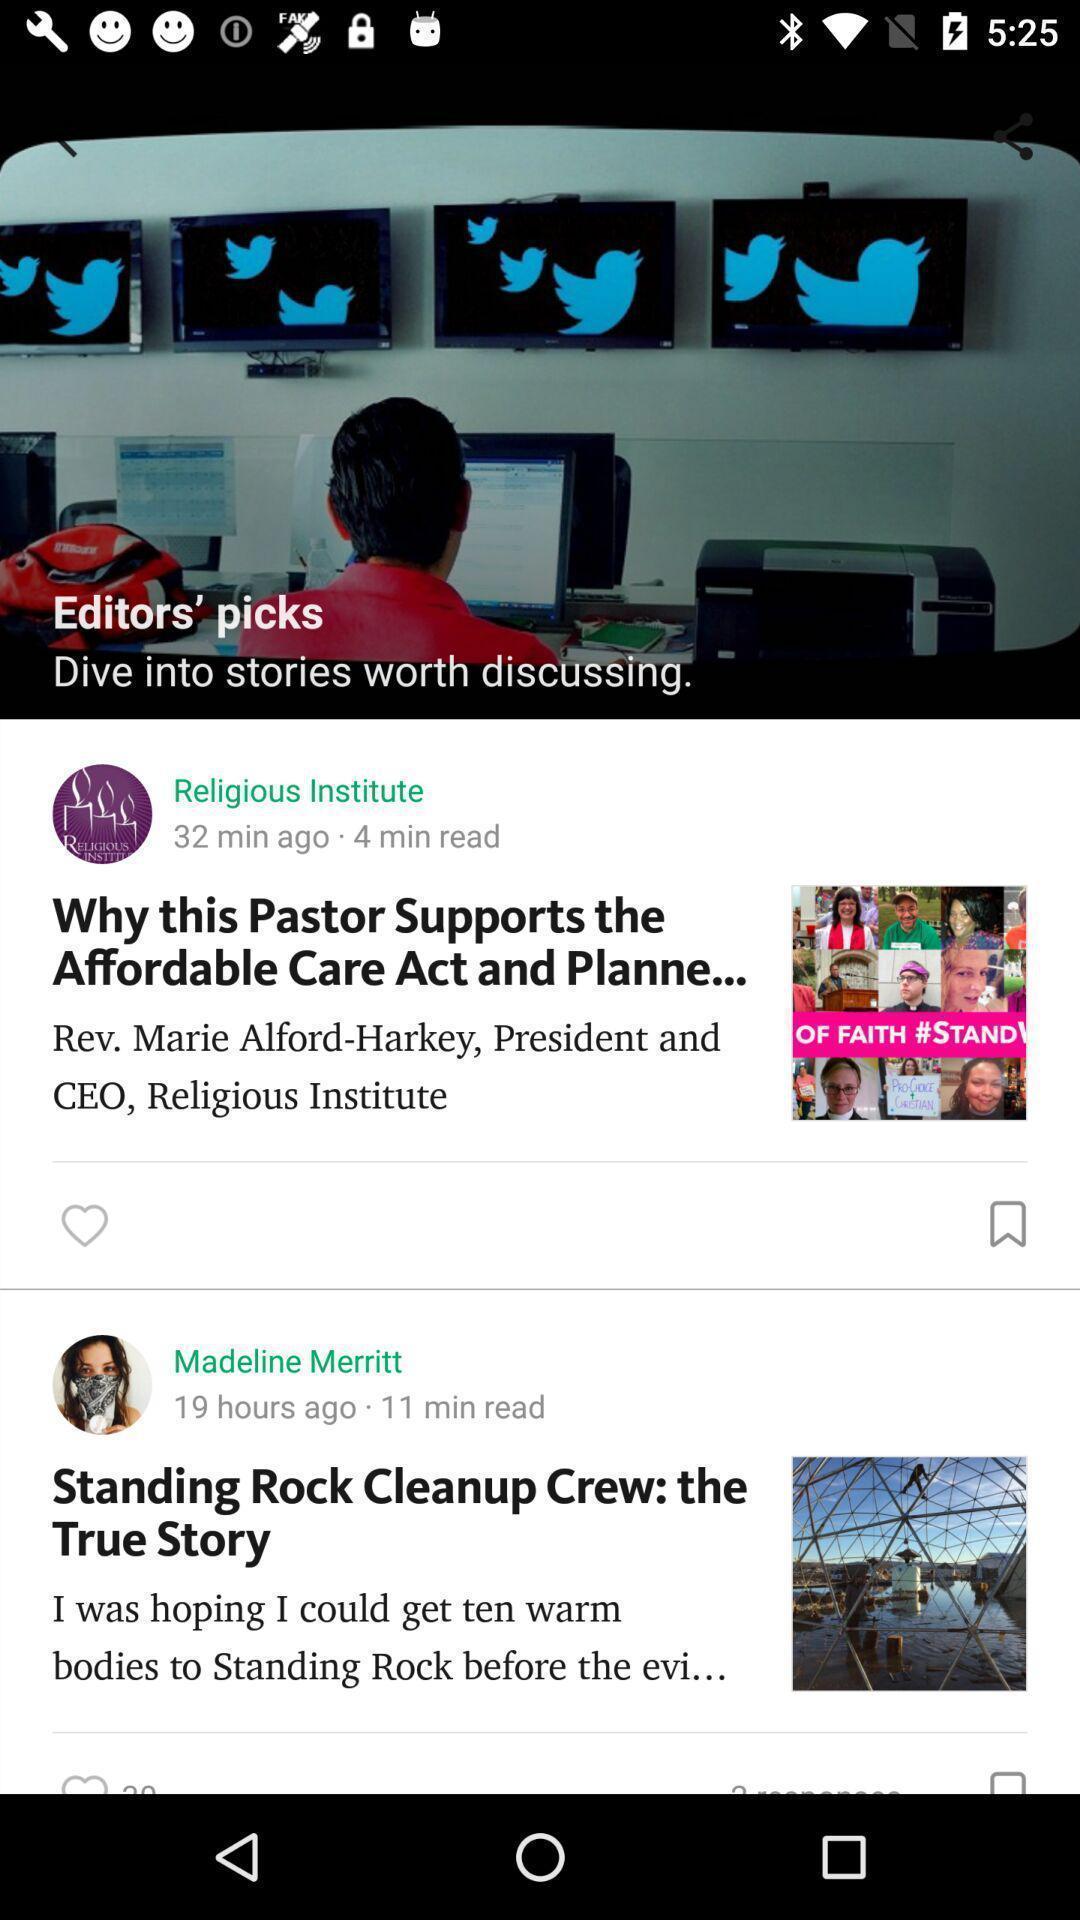Describe the content in this image. Page showing news feeds. 